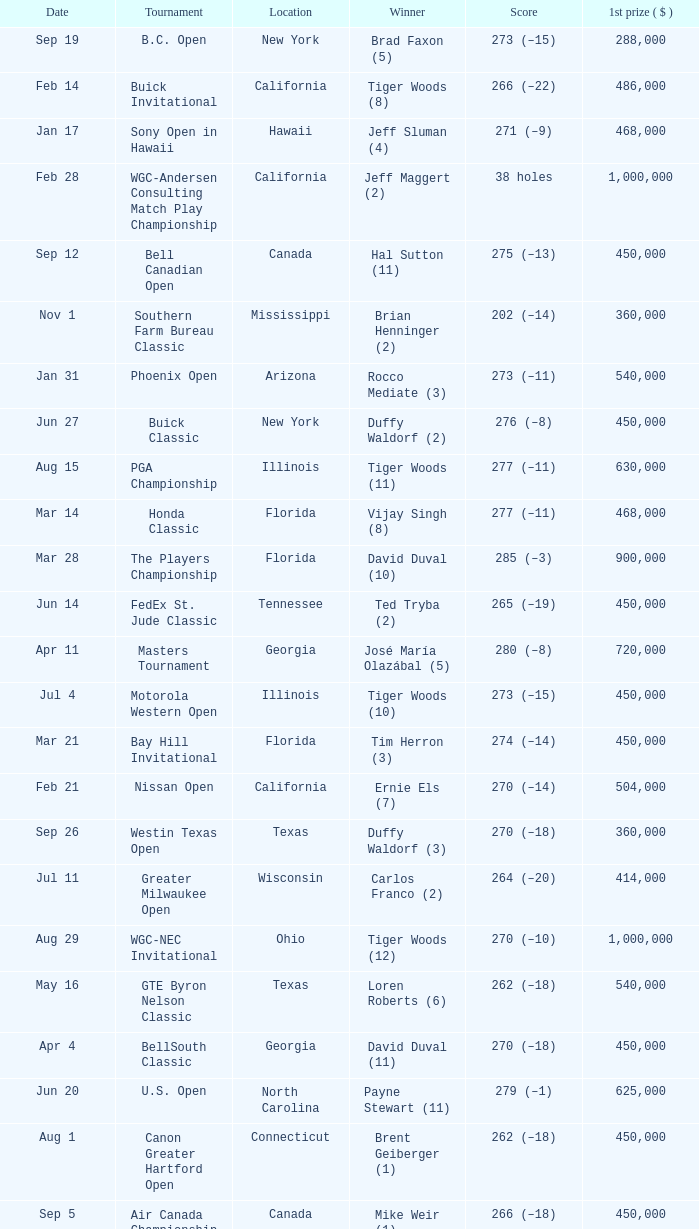What is the date of the Greater Greensboro Chrysler Classic? Apr 25. 